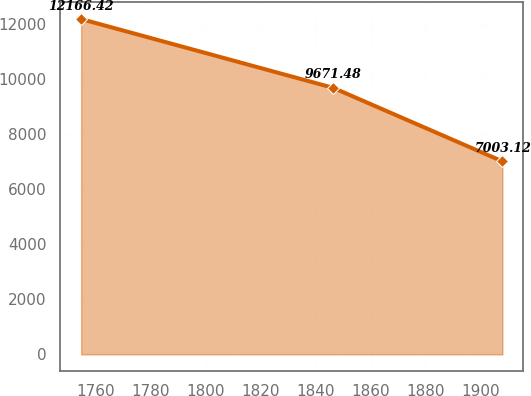Convert chart. <chart><loc_0><loc_0><loc_500><loc_500><line_chart><ecel><fcel>Unnamed: 1<nl><fcel>1754.65<fcel>12166.4<nl><fcel>1846.39<fcel>9671.48<nl><fcel>1908.02<fcel>7003.12<nl></chart> 